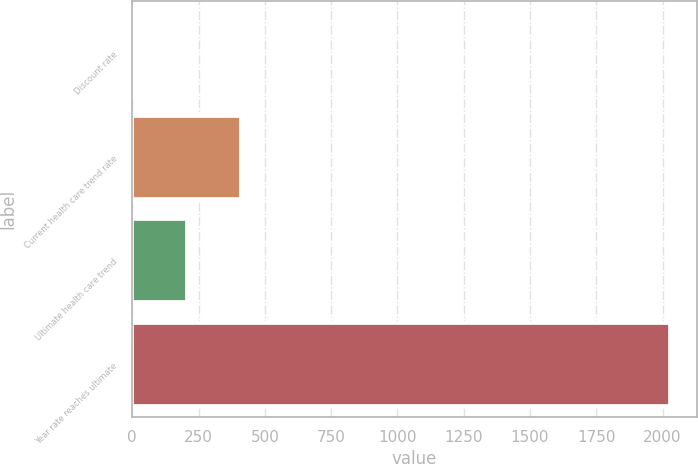<chart> <loc_0><loc_0><loc_500><loc_500><bar_chart><fcel>Discount rate<fcel>Current health care trend rate<fcel>Ultimate health care trend<fcel>Year rate reaches ultimate<nl><fcel>3.35<fcel>408.29<fcel>205.82<fcel>2028<nl></chart> 